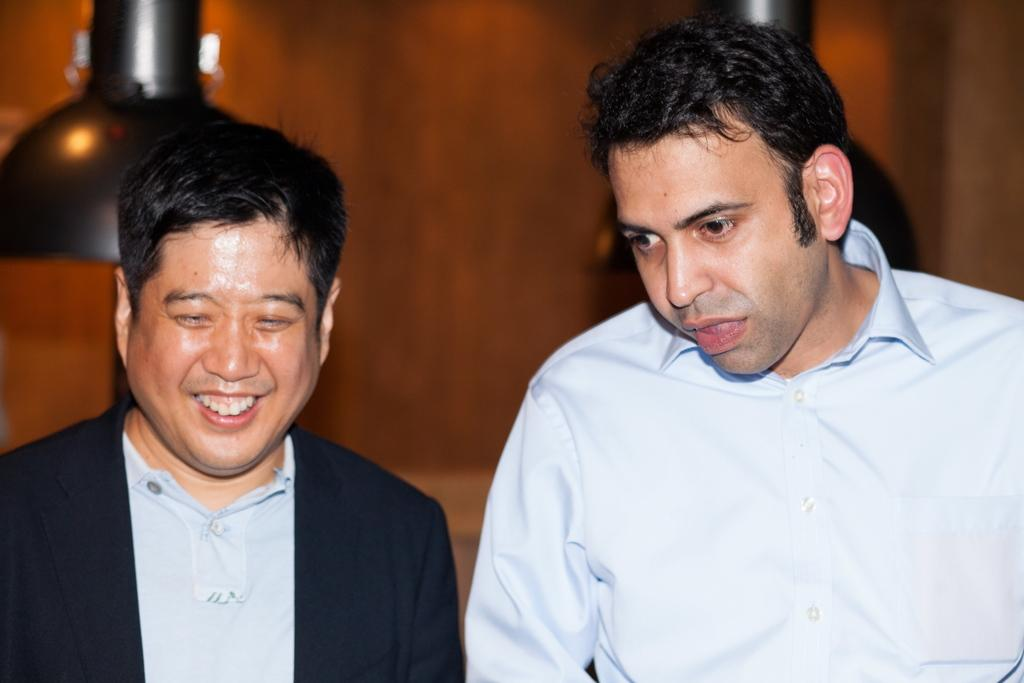How many people are in the image? There are two men in the image. What are the men wearing? Both men are wearing clothes. Can you describe the facial expression of the man on the left side? The man on the left side is smiling. How would you describe the background of the image? The background of the image is blurred. What type of magic is the man on the right side performing in the image? There is no indication of magic or any magical activity in the image. 